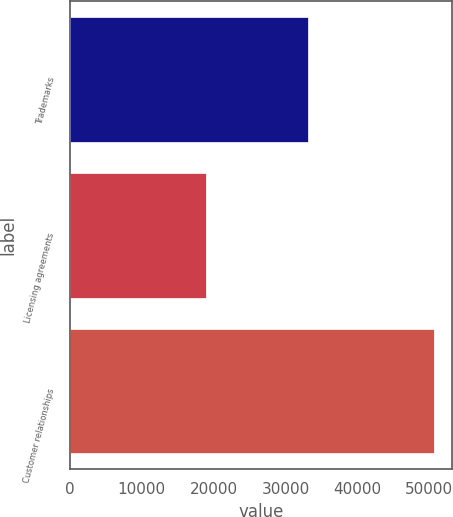Convert chart to OTSL. <chart><loc_0><loc_0><loc_500><loc_500><bar_chart><fcel>Trademarks<fcel>Licensing agreements<fcel>Customer relationships<nl><fcel>33129<fcel>18966<fcel>50632<nl></chart> 